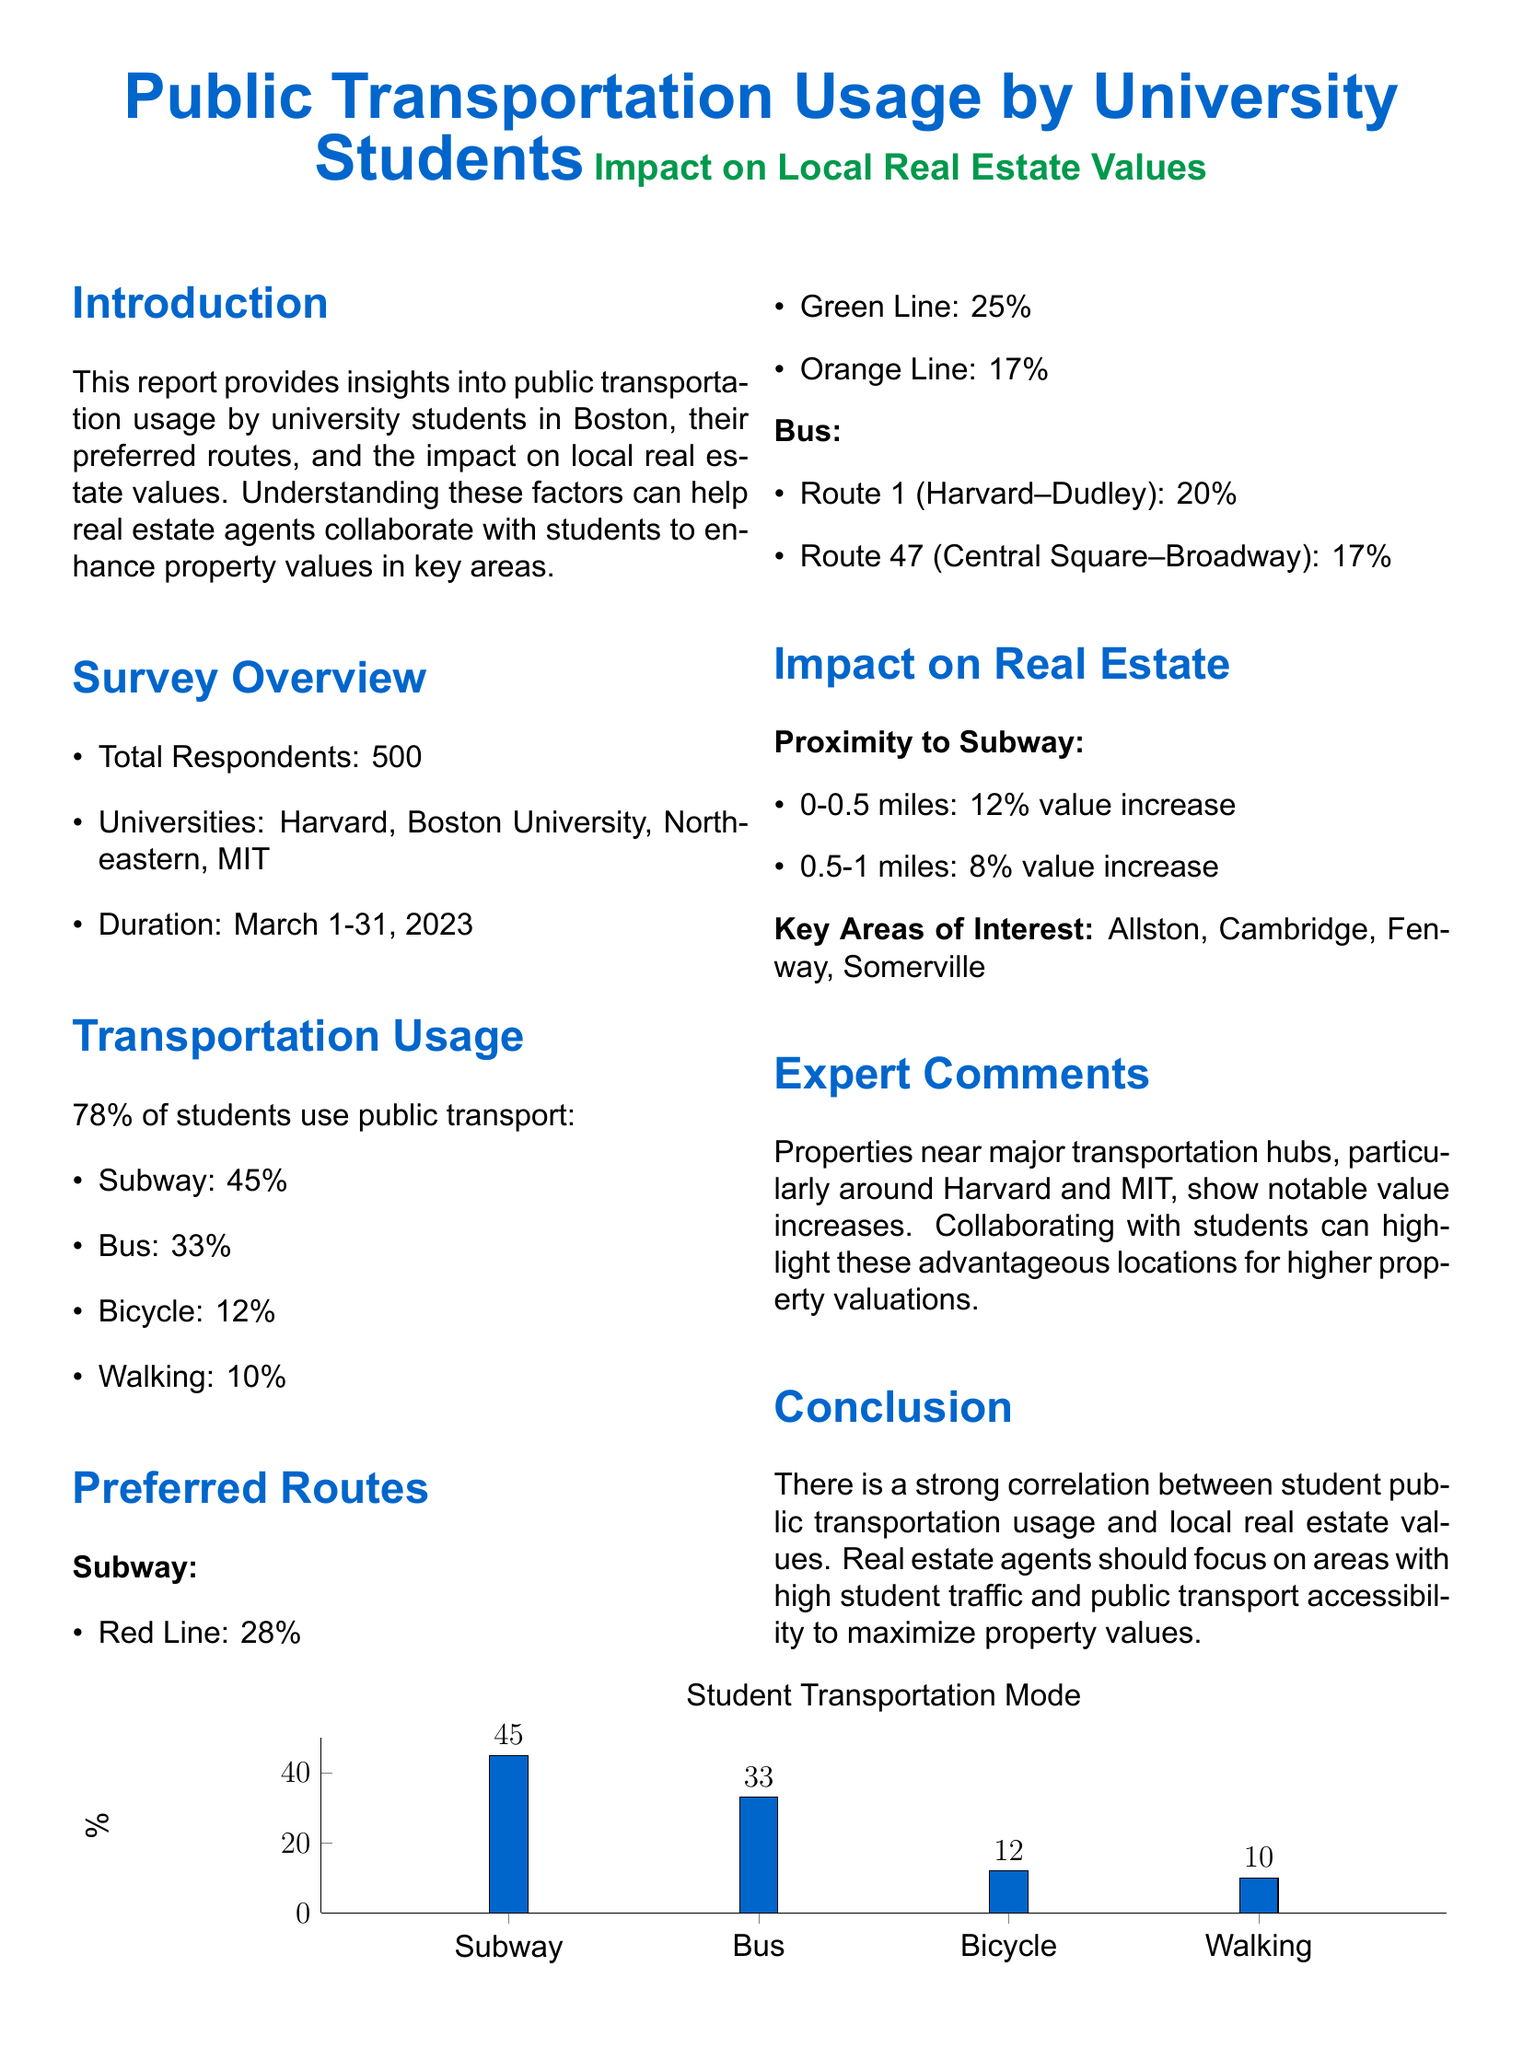what percentage of students use public transport? The report states that 78% of students use public transport.
Answer: 78% what is the most preferred subway line among students? The most preferred subway line is the Red Line, with 28% of students choosing it.
Answer: Red Line which bus route has the highest usage? The bus route with the highest usage is Route 1 (Harvard–Dudley) at 20%.
Answer: Route 1 what is the value increase for properties located 0-0.5 miles from the subway? Properties located 0-0.5 miles from the subway see a 12% value increase.
Answer: 12% which areas are noted as key areas of interest? The key areas of interest mentioned are Allston, Cambridge, Fenway, and Somerville.
Answer: Allston, Cambridge, Fenway, Somerville how long was the survey conducted? The survey was conducted over a period of one month, from March 1 to March 31, 2023.
Answer: March 1-31, 2023 what percentage of students reported walking as their mode of transport? The report indicates that 10% of students reported walking as their mode of transport.
Answer: 10% why should real estate agents focus on areas with high student traffic? The conclusion states that there is a strong correlation between student public transportation usage and local real estate values.
Answer: Strong correlation 